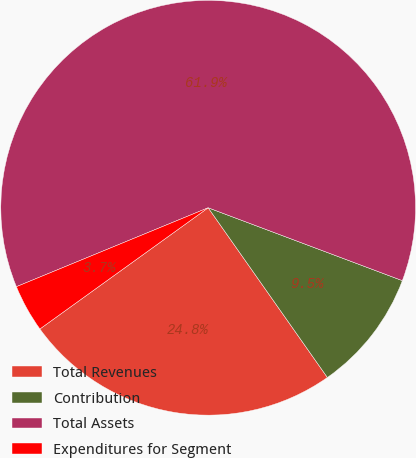Convert chart to OTSL. <chart><loc_0><loc_0><loc_500><loc_500><pie_chart><fcel>Total Revenues<fcel>Contribution<fcel>Total Assets<fcel>Expenditures for Segment<nl><fcel>24.81%<fcel>9.54%<fcel>61.93%<fcel>3.72%<nl></chart> 